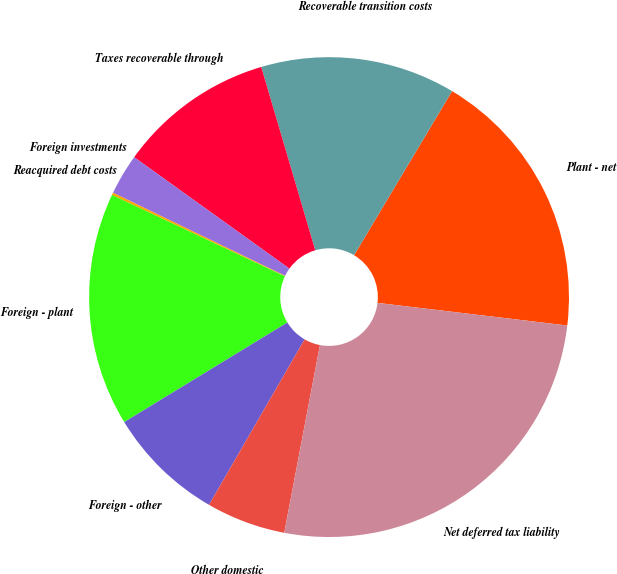<chart> <loc_0><loc_0><loc_500><loc_500><pie_chart><fcel>Plant - net<fcel>Recoverable transition costs<fcel>Taxes recoverable through<fcel>Foreign investments<fcel>Reacquired debt costs<fcel>Foreign - plant<fcel>Foreign - other<fcel>Other domestic<fcel>Net deferred tax liability<nl><fcel>18.32%<fcel>13.13%<fcel>10.53%<fcel>2.75%<fcel>0.16%<fcel>15.72%<fcel>7.94%<fcel>5.35%<fcel>26.1%<nl></chart> 